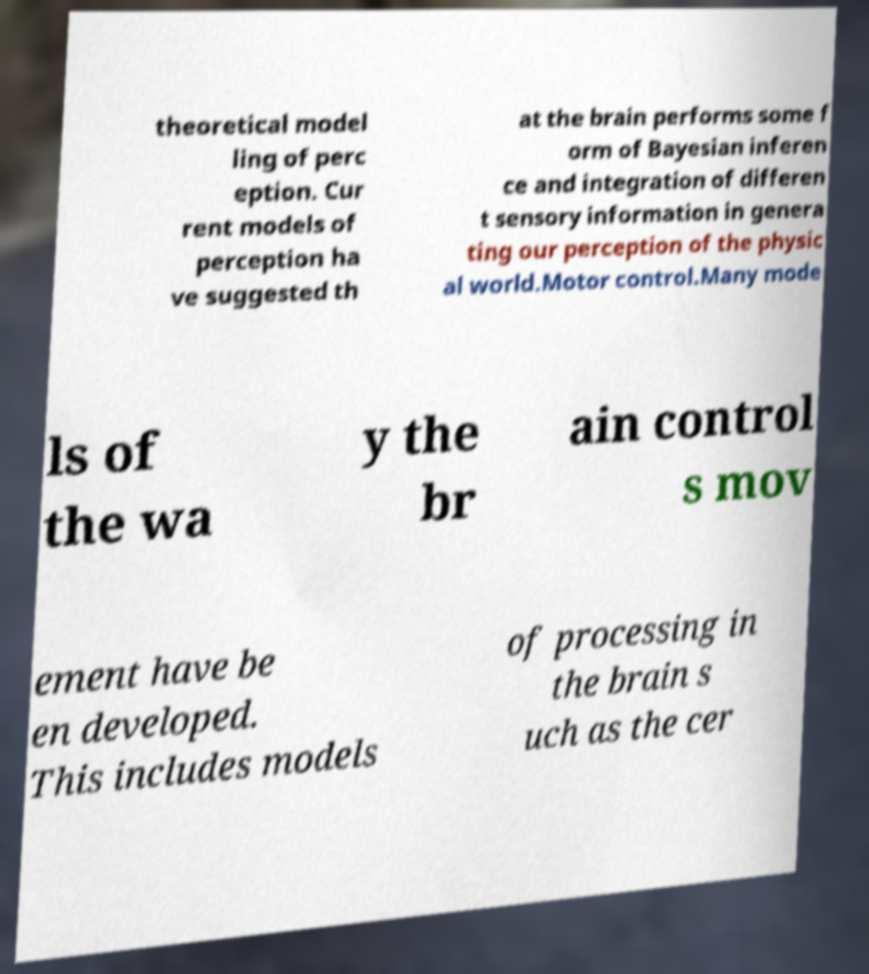Please identify and transcribe the text found in this image. theoretical model ling of perc eption. Cur rent models of perception ha ve suggested th at the brain performs some f orm of Bayesian inferen ce and integration of differen t sensory information in genera ting our perception of the physic al world.Motor control.Many mode ls of the wa y the br ain control s mov ement have be en developed. This includes models of processing in the brain s uch as the cer 